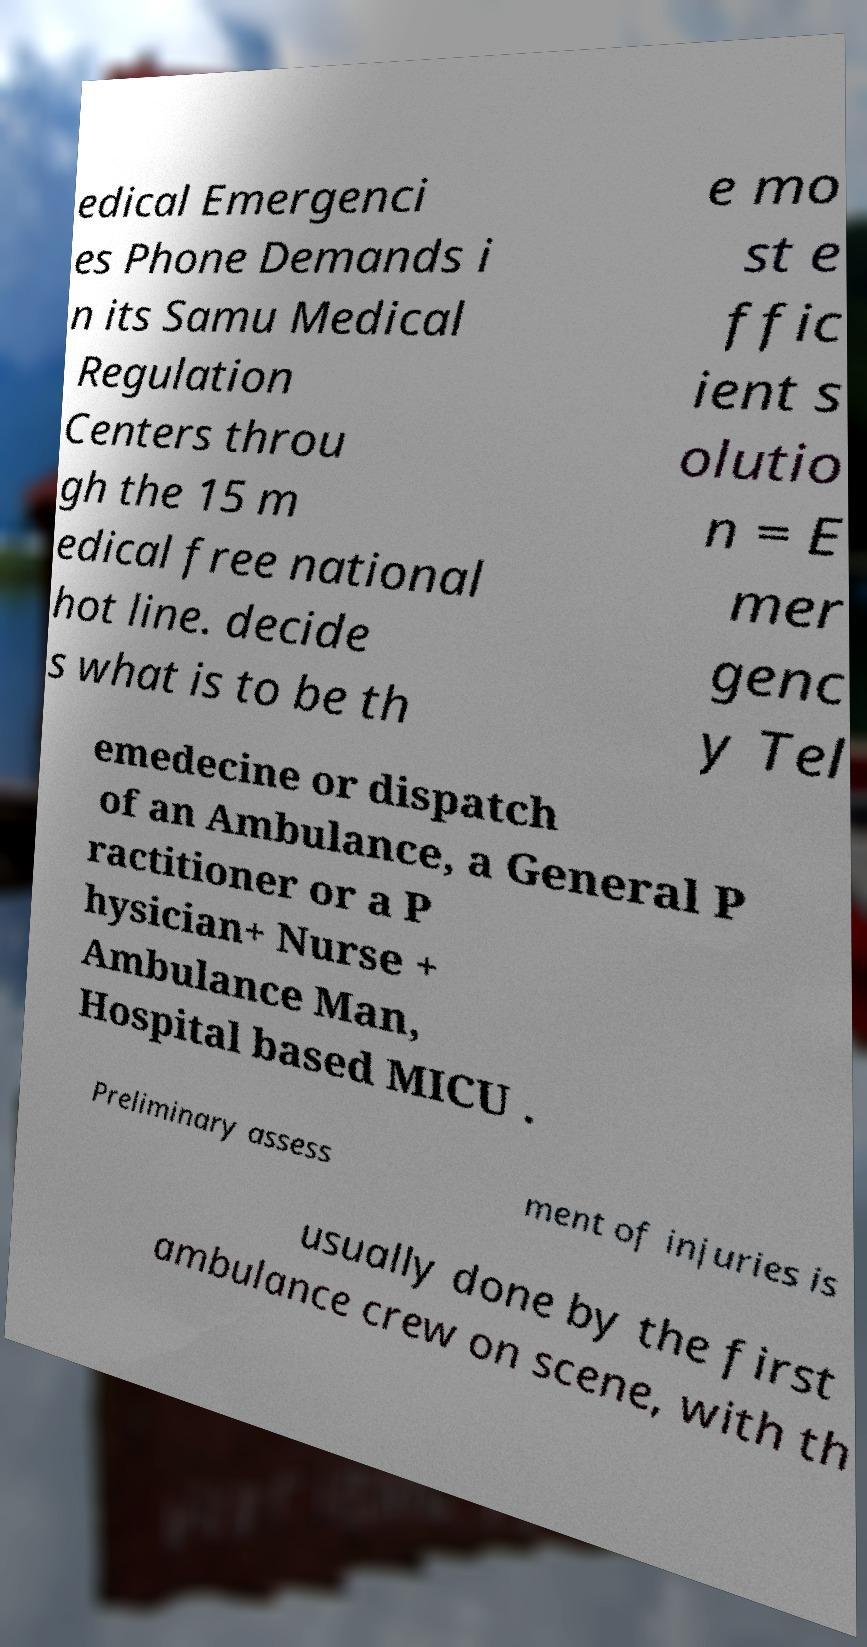Please identify and transcribe the text found in this image. edical Emergenci es Phone Demands i n its Samu Medical Regulation Centers throu gh the 15 m edical free national hot line. decide s what is to be th e mo st e ffic ient s olutio n = E mer genc y Tel emedecine or dispatch of an Ambulance, a General P ractitioner or a P hysician+ Nurse + Ambulance Man, Hospital based MICU . Preliminary assess ment of injuries is usually done by the first ambulance crew on scene, with th 